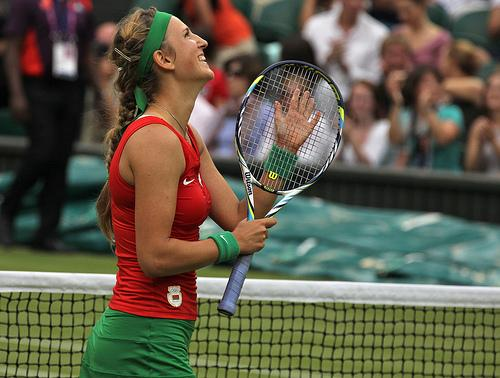What type of clothing is the woman wearing, and what brands or logos can be seen on her outfit? The woman is wearing an orange tank top, a green skirt, and a green headband. The visible logos include a Nike sign and symbol on her shirt. Identify the primary activity and the main object being used in the image. The primary activity is a woman playing tennis and the main object she is using is a multi-colored tennis racket. Give a brief description of the tennis racket being used by the woman. The tennis racket is multi-colored, with a Wilson brand name on it, and has orange, green, and black colors. What hairstyle does the woman have, and is there any unique feature about it? The woman has long, braided hair that is tied in a braided ponytail. What color is the headband worn by the tennis player, and is there any branding on it? The tennis player is wearing a green headband, there's no mention of any branding on it. How many people are watching the tennis match, and what are they doing? There's a crowd of blurred fans watching, some people in the stand are clapping, and a woman is clapping her hands. Analyze the image sentiment in the context of a tennis match. The image sentiment suggests an ongoing competitive tennis match with an attentive and enthusiastic crowd cheering for the woman player. How many sweatbands are visible in the image, and what colors are they? There are two green sweatbands visible in the image. Describe the court where the woman is playing tennis, including any notable features or objects. The court has a black and white tennis net, a green trap on the ground, and there are people watching in the stands. What kind of accessories or additional clothing items can you see in the image? There's a green Nike sweat band, a necklace, green wristband, and a man with black pants. What is the color of the tennis player's tank top in the image? Red In the image, are there more people clapping or not clapping in the stand?  Cannot accurately determine the number of people clapping or not clapping State what the woman in the image is holding. A tennis racket Identify the wrist wear on the woman's arm in the image.  Green sweatband What is the color of the headband worn by the woman in the image? Is it green, red, or blue? Green Identify the brand logo on the woman's shirt in the image. Nike Explain the position and setting of the tennis net in the image. The net is on the court near the tennis player What is the woman in the image doing? Playing tennis In the image, is the tennis net black and white or red and white?  Black and white What is the color combination on the tennis racket in the image? Multi-color Create a short poem using elements from the image. In the court of green and white, In the image, what is the color of the shirt of the person wearing black pants? Cannot determine shirt color due to lack of visibility What type of accessory is the woman in the image wearing around her neck? A necklace Construct a caption describing the outfit of the woman playing tennis. A woman playing tennis in a red tank top, green skirt, and green headband In the image, what are the people in the stands doing? Watching and clapping How is the woman's hair styled in the image? Long braided hair Describe the bottom part of the woman's outfit. Green tennis skirt 